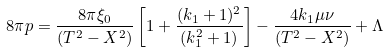Convert formula to latex. <formula><loc_0><loc_0><loc_500><loc_500>8 \pi p = \frac { 8 \pi \xi _ { 0 } } { ( T ^ { 2 } - X ^ { 2 } ) } \left [ 1 + \frac { ( k _ { 1 } + 1 ) ^ { 2 } } { ( k ^ { 2 } _ { 1 } + 1 ) } \right ] - \frac { 4 k _ { 1 } \mu \nu } { ( T ^ { 2 } - X ^ { 2 } ) } + \Lambda</formula> 